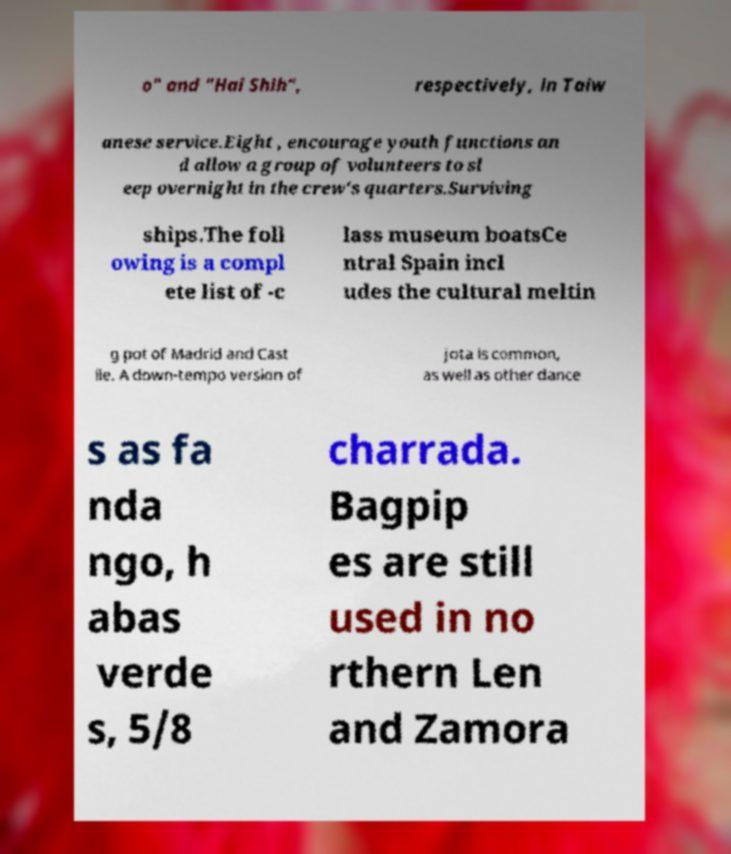Could you extract and type out the text from this image? o" and "Hai Shih", respectively, in Taiw anese service.Eight , encourage youth functions an d allow a group of volunteers to sl eep overnight in the crew's quarters.Surviving ships.The foll owing is a compl ete list of -c lass museum boatsCe ntral Spain incl udes the cultural meltin g pot of Madrid and Cast ile. A down-tempo version of jota is common, as well as other dance s as fa nda ngo, h abas verde s, 5/8 charrada. Bagpip es are still used in no rthern Len and Zamora 